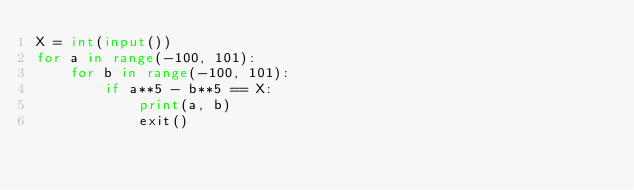Convert code to text. <code><loc_0><loc_0><loc_500><loc_500><_Python_>X = int(input())
for a in range(-100, 101):
    for b in range(-100, 101):
        if a**5 - b**5 == X:
            print(a, b)
            exit()
</code> 